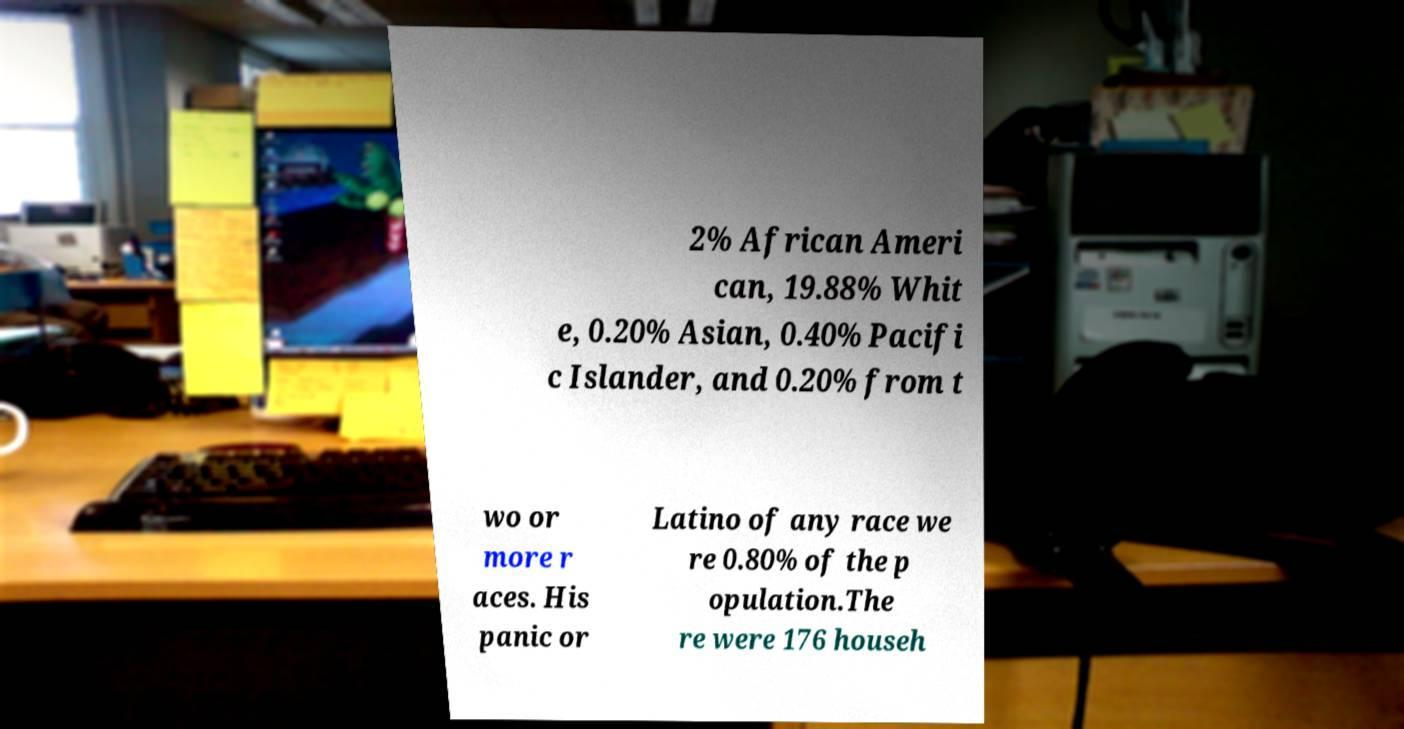Can you accurately transcribe the text from the provided image for me? 2% African Ameri can, 19.88% Whit e, 0.20% Asian, 0.40% Pacifi c Islander, and 0.20% from t wo or more r aces. His panic or Latino of any race we re 0.80% of the p opulation.The re were 176 househ 